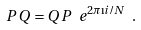<formula> <loc_0><loc_0><loc_500><loc_500>P \, Q = Q \, P \ e ^ { { 2 \pi \i i } / { N } } \ .</formula> 